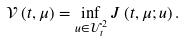<formula> <loc_0><loc_0><loc_500><loc_500>\mathcal { V } \left ( t , \mu \right ) = \inf _ { u \in \mathcal { U } _ { t } ^ { 2 } } J \left ( t , \mu ; u \right ) .</formula> 